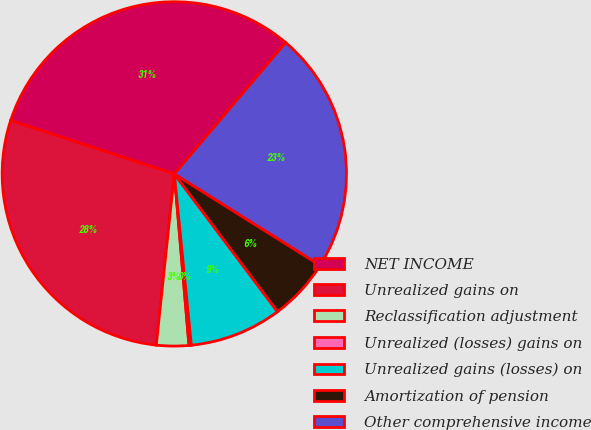<chart> <loc_0><loc_0><loc_500><loc_500><pie_chart><fcel>NET INCOME<fcel>Unrealized gains on<fcel>Reclassification adjustment<fcel>Unrealized (losses) gains on<fcel>Unrealized gains (losses) on<fcel>Amortization of pension<fcel>Other comprehensive income<nl><fcel>31.17%<fcel>28.35%<fcel>3.03%<fcel>0.22%<fcel>8.66%<fcel>5.85%<fcel>22.73%<nl></chart> 